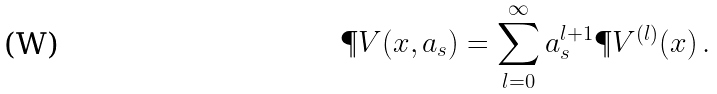<formula> <loc_0><loc_0><loc_500><loc_500>\P V ( x , a _ { s } ) = \sum _ { l = 0 } ^ { \infty } a _ { s } ^ { l + 1 } \P V ^ { ( l ) } ( x ) \, .</formula> 